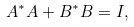Convert formula to latex. <formula><loc_0><loc_0><loc_500><loc_500>A ^ { * } A + B ^ { * } B = I ,</formula> 